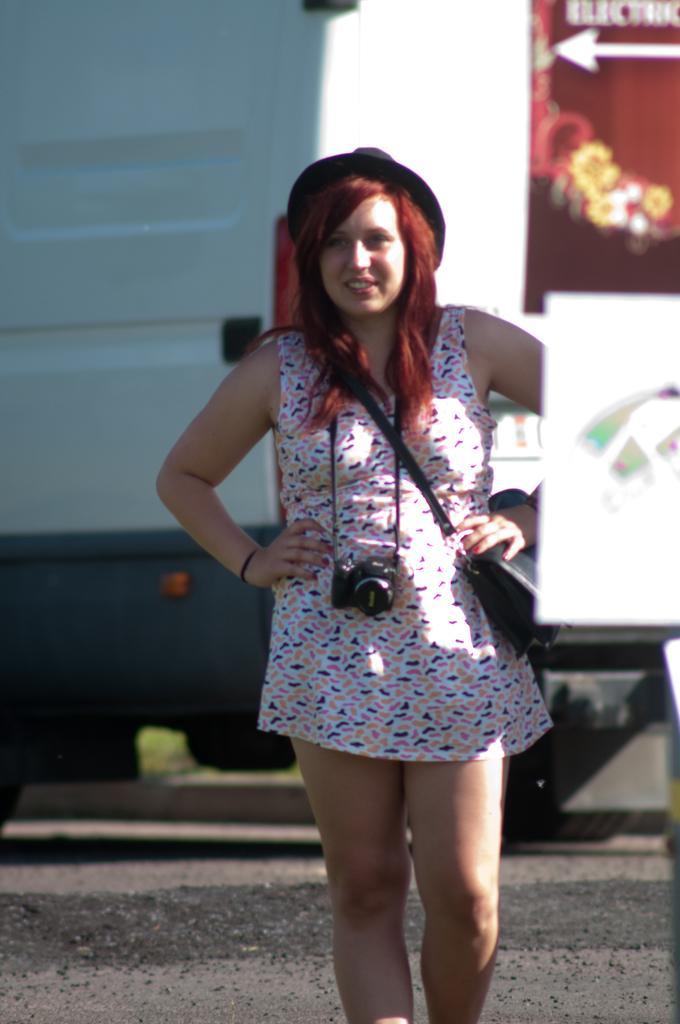How would you summarize this image in a sentence or two? In this image there is a woman wearing a camera and a bag standing on a road, in the background it is blurred. 